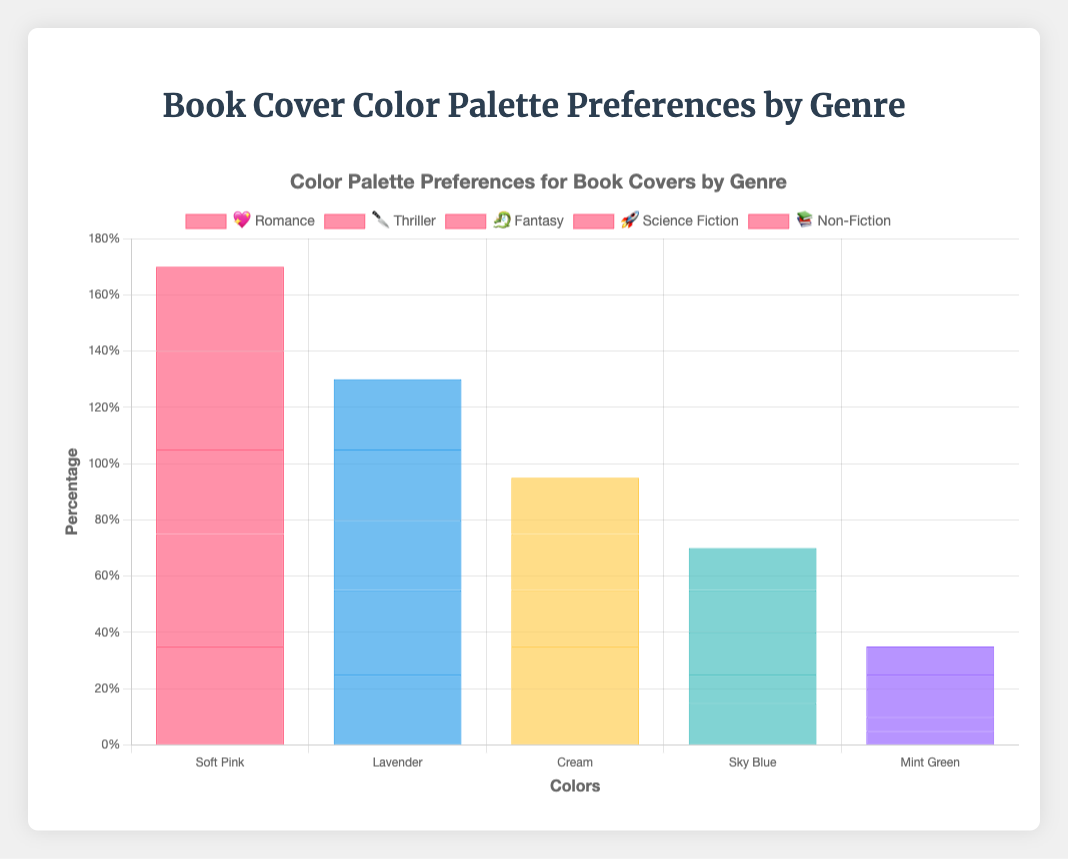What are the top two most preferred colors for Romance book covers? 💖 By looking at the color distribution for the Romance genre, we can see that the Soft Pink color has the highest percentage at 35%, followed by Lavender at 25%.
Answer: Soft Pink (35%) and Lavender (25%) Which genre uses Black the most? 🔪 Observing the color preferences for different genres, Thriller has the highest percentage of Black usage at 40%.
Answer: Thriller What is the combined percentage of Electric Blue and Neon Green for Science Fiction book covers? 🚀 Science Fiction has Electric Blue at 35% and Neon Green at 25%. Combining these percentages, we get 35 + 25 = 60%.
Answer: 60% How does the preference for Navy Blue in Non-Fiction compare to that in Thriller? 📚 🔪 Navy Blue is preferred at 30% in Non-Fiction and 15% in Thriller. Comparing the two, Navy Blue preference in Non-Fiction is 15% higher than in Thriller.
Answer: 15% higher in Non-Fiction Which genre has the most diverse color palette, considering the number of colors with significant percentages? 🐉 Fantasy has a more diverse color palette with noticeable percentages spread across five colors: Deep Purple (30%), Emerald Green (25%), Midnight Blue (20%), Gold (15%), and Silver (10%).
Answer: Fantasy Which color has the lowest preference percentage across all genres? 🎨 By checking the last color in each genre, we find that Mint Green in Romance and Bright Orange in Science Fiction both have the lowest preference at 5%.
Answer: Mint Green and Bright Orange How much higher is the preference for Soft Pink in Romance compared to Mint Green? 💖 The preference for Soft Pink is 35%, and for Mint Green, it is 5%. The difference is 35 - 5 = 30%.
Answer: 30% Which genre has the highest percentage for a single color, and what is it? 🔪 Thriller has the highest percentage for a single color, with Black at 40%.
Answer: Thriller with Black at 40% What is the percentage difference between the most and least preferred colors in Fantasy book covers? 🐉 For Fantasy, the most preferred color is Deep Purple at 30% and the least preferred is Silver at 10%. The difference is 30 - 10 = 20%.
Answer: 20% Which genre has the closest percentage distribution among its top two colors, and what are the colors? 📚 Non-Fiction has the closest percentage distribution among the top two colors: Navy Blue at 30% and White at 25%. The difference is 30 - 25 = 5%.
Answer: Non-Fiction with Navy Blue and White 